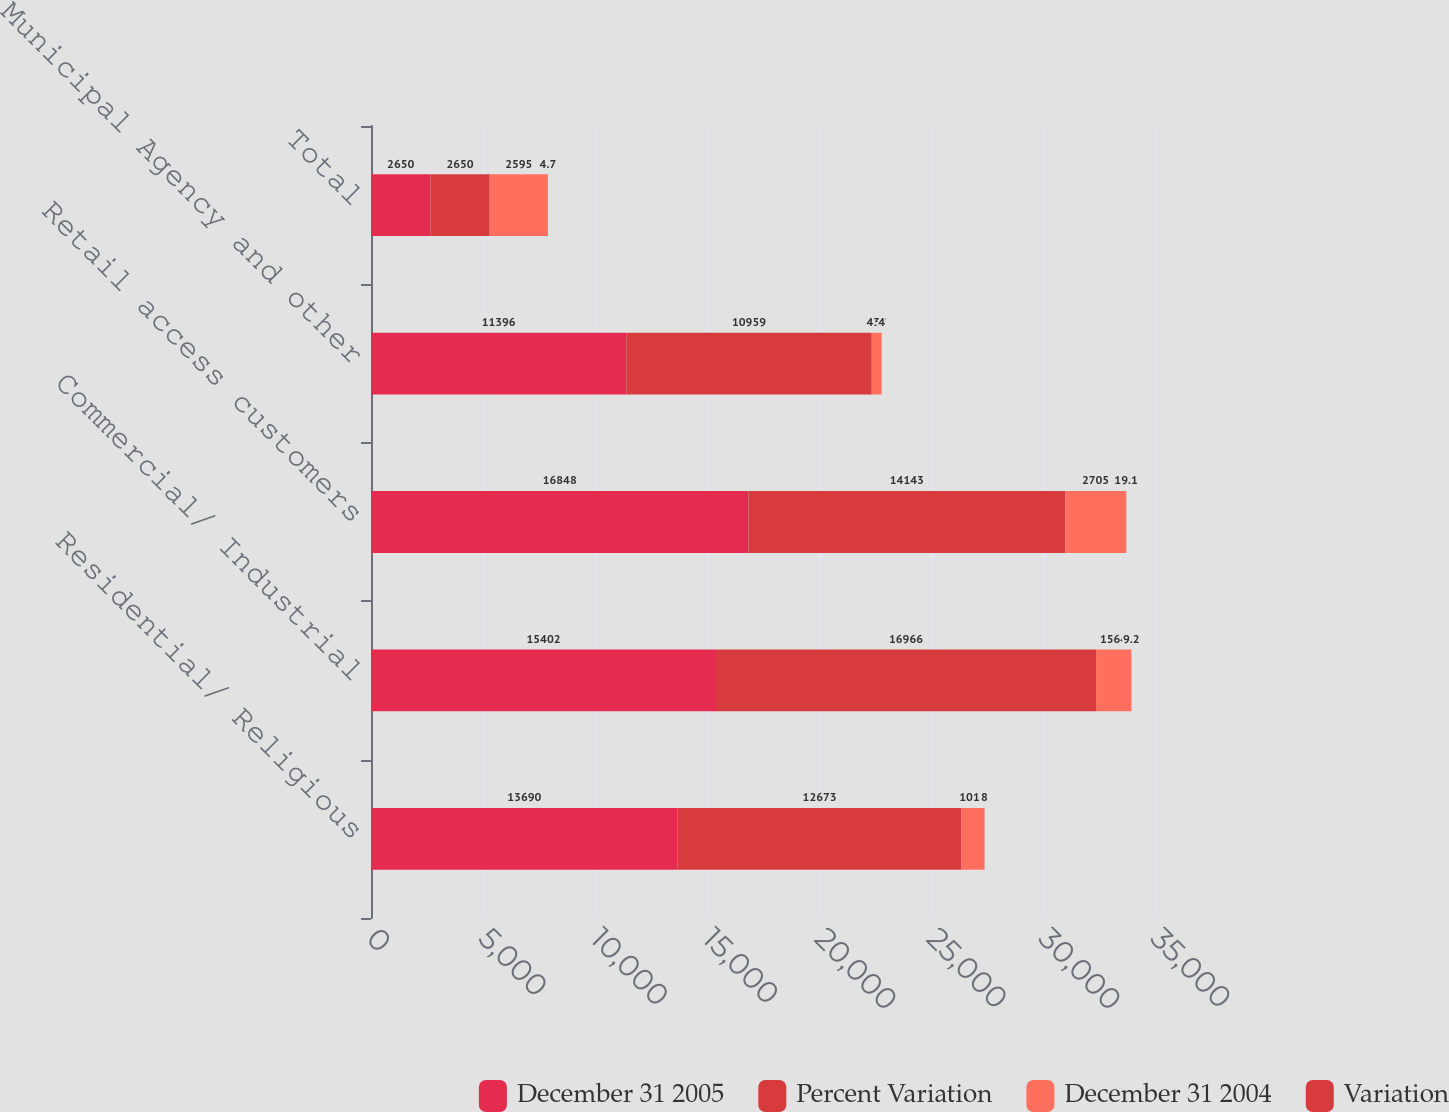Convert chart. <chart><loc_0><loc_0><loc_500><loc_500><stacked_bar_chart><ecel><fcel>Residential/ Religious<fcel>Commercial/ Industrial<fcel>Retail access customers<fcel>Municipal Agency and other<fcel>Total<nl><fcel>December 31 2005<fcel>13690<fcel>15402<fcel>16848<fcel>11396<fcel>2650<nl><fcel>Percent Variation<fcel>12673<fcel>16966<fcel>14143<fcel>10959<fcel>2650<nl><fcel>December 31 2004<fcel>1017<fcel>1564<fcel>2705<fcel>437<fcel>2595<nl><fcel>Variation<fcel>8<fcel>9.2<fcel>19.1<fcel>4<fcel>4.7<nl></chart> 